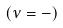Convert formula to latex. <formula><loc_0><loc_0><loc_500><loc_500>( \nu = - )</formula> 